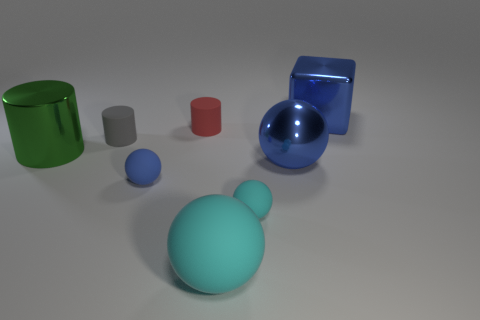Are there any other things that are the same size as the gray matte thing?
Give a very brief answer. Yes. How many cubes are either tiny blue objects or matte things?
Keep it short and to the point. 0. What number of objects are either tiny things that are in front of the small blue rubber sphere or tiny brown cylinders?
Provide a short and direct response. 1. There is a tiny rubber thing on the right side of the big ball that is in front of the blue ball on the right side of the red matte thing; what shape is it?
Give a very brief answer. Sphere. What number of big cyan things are the same shape as the gray matte object?
Your answer should be very brief. 0. There is a sphere that is the same color as the big matte object; what is it made of?
Provide a succinct answer. Rubber. Is the material of the red thing the same as the big cyan sphere?
Make the answer very short. Yes. How many tiny red rubber objects are in front of the metallic thing right of the big metallic ball left of the big cube?
Provide a short and direct response. 1. Is there a cylinder that has the same material as the blue cube?
Your answer should be compact. Yes. There is another thing that is the same color as the big matte thing; what size is it?
Ensure brevity in your answer.  Small. 